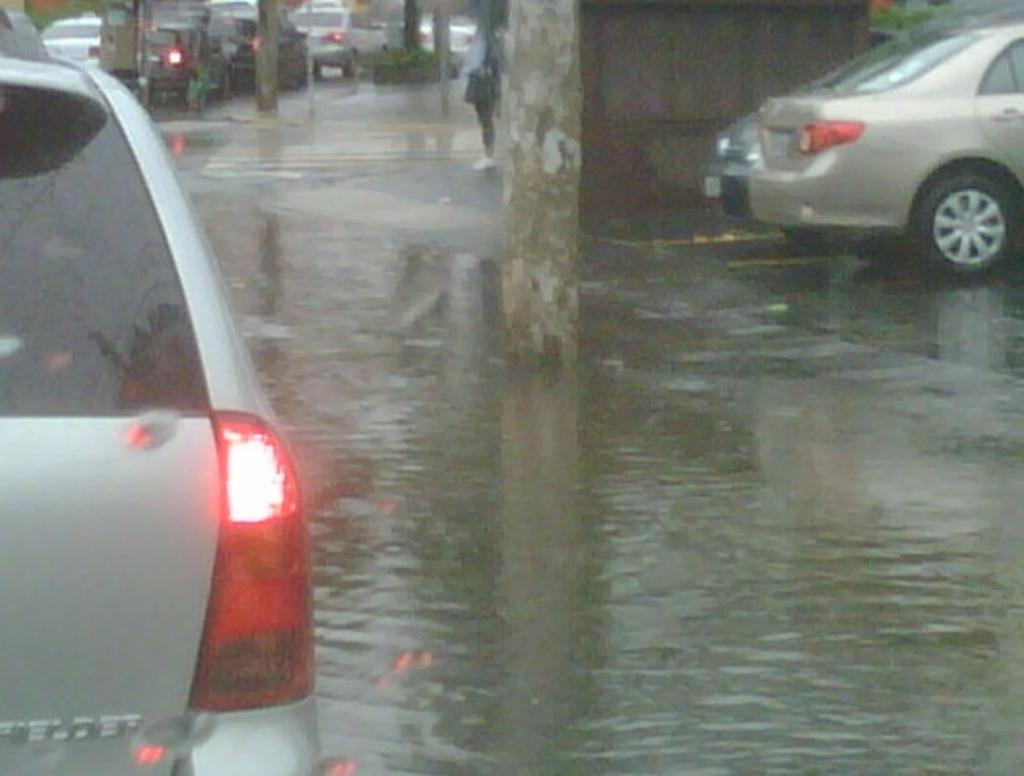What is the primary element visible in the image? There is water in the image. What type of plant structure can be seen in the image? There is a tree stem in the image. What type of man-made objects are present in the image? There are cars in the image. What type of structure can be seen in the image? There is a wall in the image. What type of insect can be seen making a joke in the image? There is no insect present in the image, and therefore no such activity can be observed. 